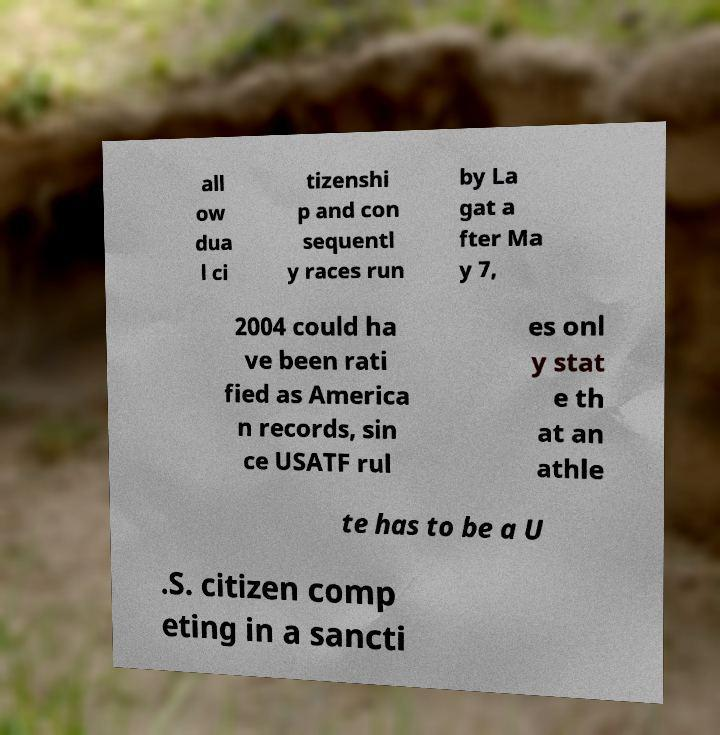Could you extract and type out the text from this image? all ow dua l ci tizenshi p and con sequentl y races run by La gat a fter Ma y 7, 2004 could ha ve been rati fied as America n records, sin ce USATF rul es onl y stat e th at an athle te has to be a U .S. citizen comp eting in a sancti 